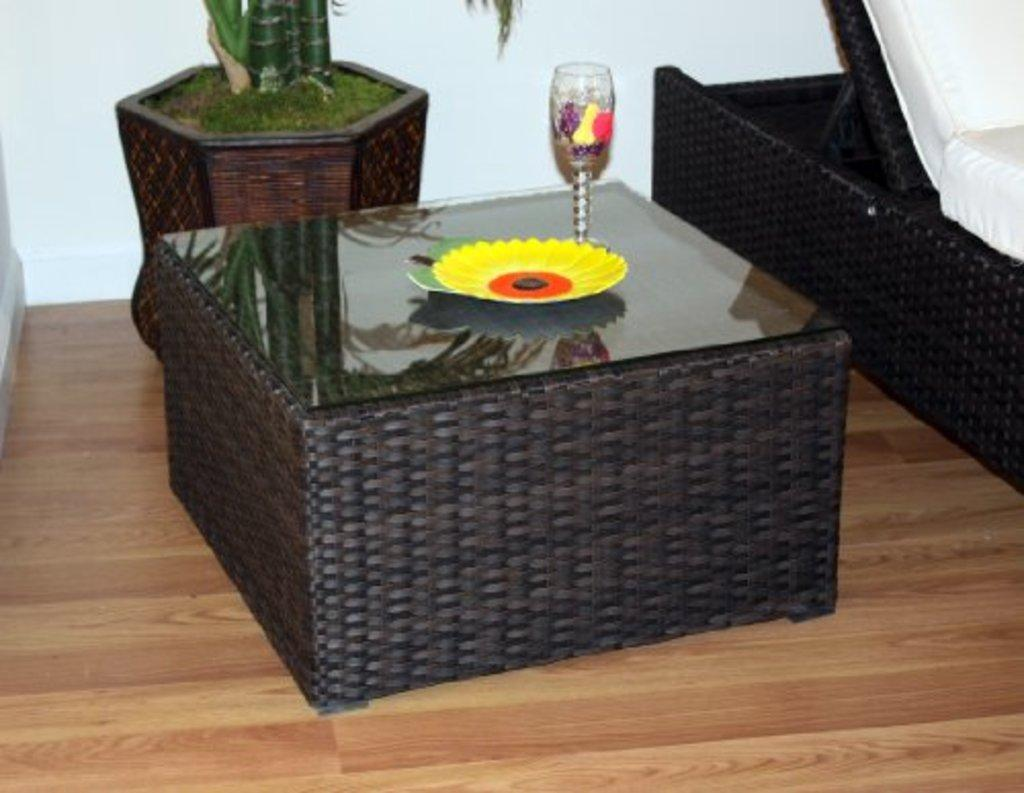What is on the table in the image? There is a plate and a glass on the table in the image. What type of furniture is in the image? There is a sofa in the image. What kind of plant is present in the image? There is a house plant in the image. What can be seen on the floor in the image? The floor is visible in the image. What is in the background of the image? There is a wall in the background of the image. How many zippers can be seen on the sofa in the image? There are no zippers visible on the sofa in the image. What type of form is the house plant taking in the image? The house plant is not taking any specific form in the image; it is simply a plant. 